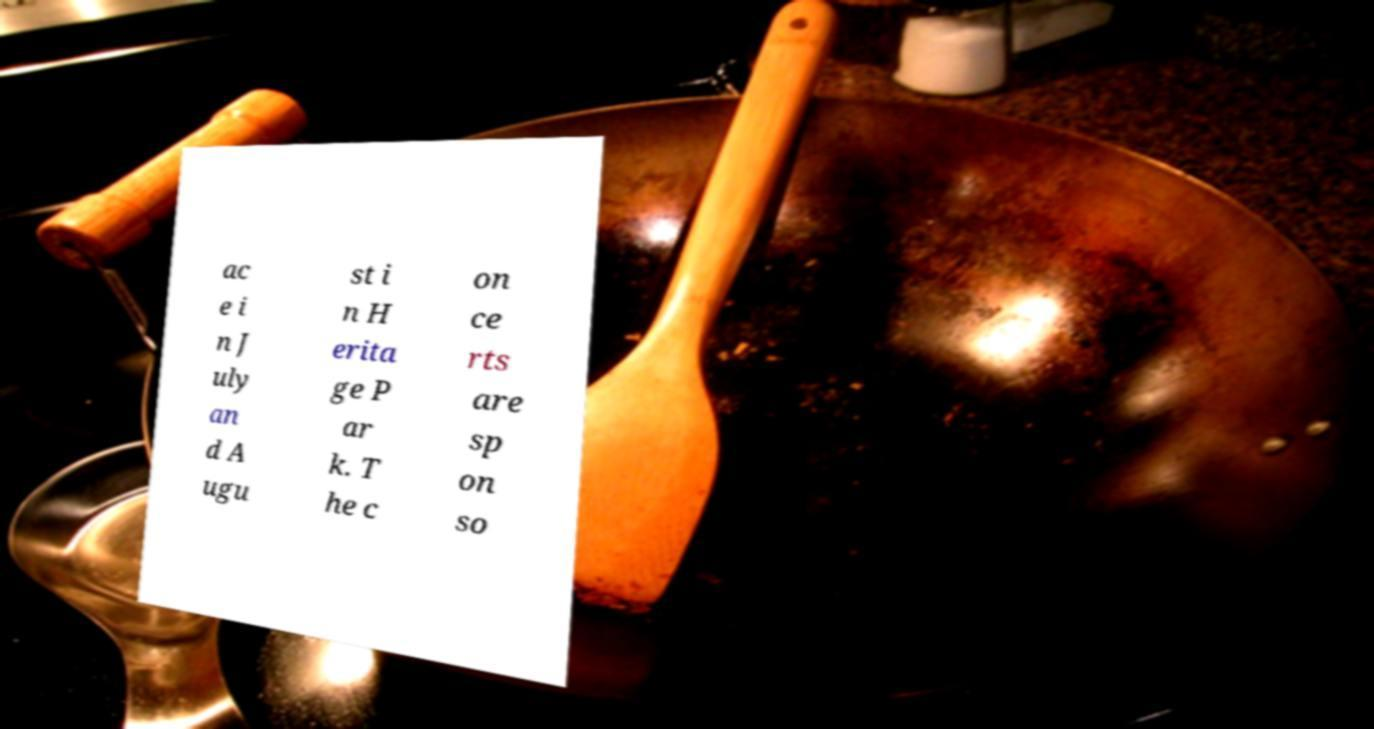Can you read and provide the text displayed in the image?This photo seems to have some interesting text. Can you extract and type it out for me? ac e i n J uly an d A ugu st i n H erita ge P ar k. T he c on ce rts are sp on so 